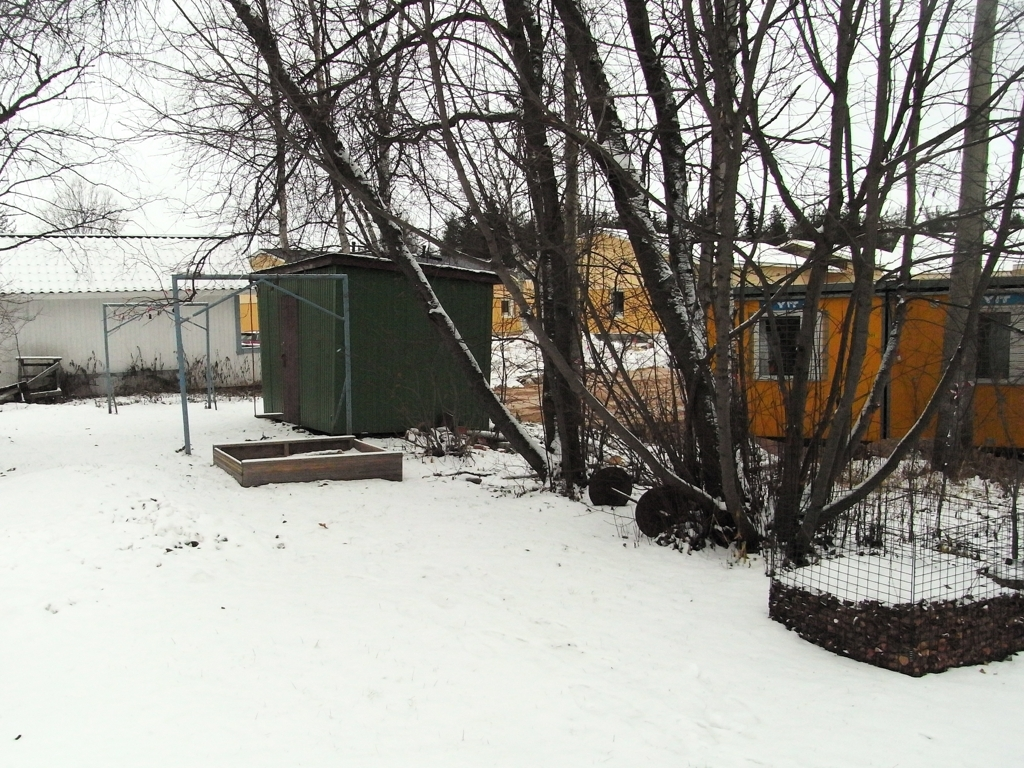Is there any sign of recent human activity in this image? There are no direct indications of recent human activity such as footprints in the snow or items indicating ongoing work or recreation. However, the fenced areas and maintenance of the buildings suggest that the area is attended to, although not necessarily at the moment the photo was taken. 